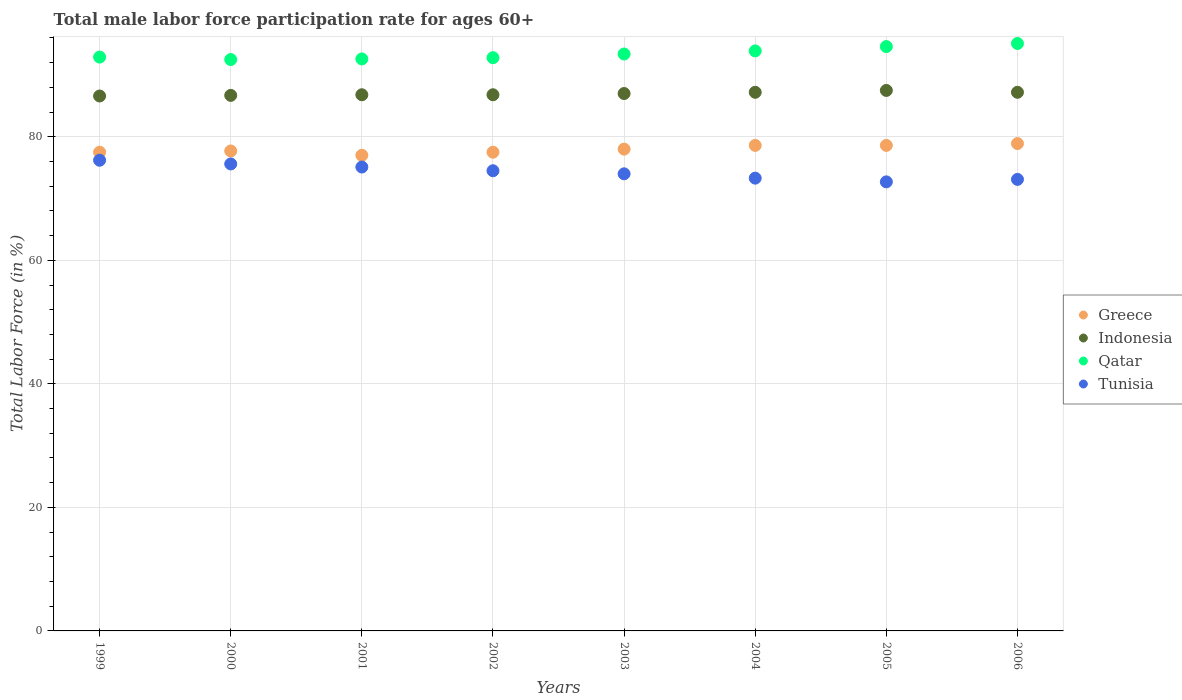How many different coloured dotlines are there?
Provide a short and direct response. 4. Is the number of dotlines equal to the number of legend labels?
Provide a succinct answer. Yes. Across all years, what is the maximum male labor force participation rate in Greece?
Ensure brevity in your answer.  78.9. Across all years, what is the minimum male labor force participation rate in Qatar?
Ensure brevity in your answer.  92.5. What is the total male labor force participation rate in Qatar in the graph?
Make the answer very short. 747.8. What is the difference between the male labor force participation rate in Qatar in 2006 and the male labor force participation rate in Indonesia in 1999?
Keep it short and to the point. 8.5. What is the average male labor force participation rate in Indonesia per year?
Your response must be concise. 86.97. In the year 2001, what is the difference between the male labor force participation rate in Greece and male labor force participation rate in Indonesia?
Offer a very short reply. -9.8. What is the ratio of the male labor force participation rate in Indonesia in 2000 to that in 2006?
Your answer should be very brief. 0.99. Is the difference between the male labor force participation rate in Greece in 2000 and 2005 greater than the difference between the male labor force participation rate in Indonesia in 2000 and 2005?
Your answer should be compact. No. What is the difference between the highest and the second highest male labor force participation rate in Tunisia?
Offer a very short reply. 0.6. What is the difference between the highest and the lowest male labor force participation rate in Indonesia?
Provide a succinct answer. 0.9. In how many years, is the male labor force participation rate in Qatar greater than the average male labor force participation rate in Qatar taken over all years?
Offer a very short reply. 3. Is the sum of the male labor force participation rate in Greece in 2000 and 2002 greater than the maximum male labor force participation rate in Qatar across all years?
Offer a very short reply. Yes. Is it the case that in every year, the sum of the male labor force participation rate in Tunisia and male labor force participation rate in Qatar  is greater than the sum of male labor force participation rate in Indonesia and male labor force participation rate in Greece?
Provide a succinct answer. No. Does the male labor force participation rate in Greece monotonically increase over the years?
Your answer should be very brief. No. Is the male labor force participation rate in Qatar strictly greater than the male labor force participation rate in Greece over the years?
Keep it short and to the point. Yes. How many dotlines are there?
Give a very brief answer. 4. How many years are there in the graph?
Your answer should be compact. 8. What is the difference between two consecutive major ticks on the Y-axis?
Make the answer very short. 20. Does the graph contain any zero values?
Keep it short and to the point. No. Where does the legend appear in the graph?
Offer a terse response. Center right. How are the legend labels stacked?
Keep it short and to the point. Vertical. What is the title of the graph?
Give a very brief answer. Total male labor force participation rate for ages 60+. What is the Total Labor Force (in %) in Greece in 1999?
Your response must be concise. 77.5. What is the Total Labor Force (in %) in Indonesia in 1999?
Your answer should be very brief. 86.6. What is the Total Labor Force (in %) of Qatar in 1999?
Ensure brevity in your answer.  92.9. What is the Total Labor Force (in %) of Tunisia in 1999?
Give a very brief answer. 76.2. What is the Total Labor Force (in %) of Greece in 2000?
Keep it short and to the point. 77.7. What is the Total Labor Force (in %) in Indonesia in 2000?
Make the answer very short. 86.7. What is the Total Labor Force (in %) of Qatar in 2000?
Your answer should be compact. 92.5. What is the Total Labor Force (in %) in Tunisia in 2000?
Ensure brevity in your answer.  75.6. What is the Total Labor Force (in %) of Indonesia in 2001?
Your answer should be compact. 86.8. What is the Total Labor Force (in %) of Qatar in 2001?
Offer a very short reply. 92.6. What is the Total Labor Force (in %) in Tunisia in 2001?
Provide a short and direct response. 75.1. What is the Total Labor Force (in %) of Greece in 2002?
Provide a succinct answer. 77.5. What is the Total Labor Force (in %) in Indonesia in 2002?
Offer a terse response. 86.8. What is the Total Labor Force (in %) in Qatar in 2002?
Provide a short and direct response. 92.8. What is the Total Labor Force (in %) of Tunisia in 2002?
Provide a succinct answer. 74.5. What is the Total Labor Force (in %) of Greece in 2003?
Your answer should be compact. 78. What is the Total Labor Force (in %) in Indonesia in 2003?
Keep it short and to the point. 87. What is the Total Labor Force (in %) in Qatar in 2003?
Offer a terse response. 93.4. What is the Total Labor Force (in %) of Tunisia in 2003?
Your answer should be very brief. 74. What is the Total Labor Force (in %) in Greece in 2004?
Provide a short and direct response. 78.6. What is the Total Labor Force (in %) of Indonesia in 2004?
Ensure brevity in your answer.  87.2. What is the Total Labor Force (in %) of Qatar in 2004?
Provide a short and direct response. 93.9. What is the Total Labor Force (in %) in Tunisia in 2004?
Provide a short and direct response. 73.3. What is the Total Labor Force (in %) of Greece in 2005?
Your response must be concise. 78.6. What is the Total Labor Force (in %) in Indonesia in 2005?
Provide a short and direct response. 87.5. What is the Total Labor Force (in %) in Qatar in 2005?
Your answer should be compact. 94.6. What is the Total Labor Force (in %) of Tunisia in 2005?
Give a very brief answer. 72.7. What is the Total Labor Force (in %) of Greece in 2006?
Give a very brief answer. 78.9. What is the Total Labor Force (in %) in Indonesia in 2006?
Provide a succinct answer. 87.2. What is the Total Labor Force (in %) of Qatar in 2006?
Your answer should be very brief. 95.1. What is the Total Labor Force (in %) of Tunisia in 2006?
Make the answer very short. 73.1. Across all years, what is the maximum Total Labor Force (in %) in Greece?
Offer a terse response. 78.9. Across all years, what is the maximum Total Labor Force (in %) in Indonesia?
Offer a very short reply. 87.5. Across all years, what is the maximum Total Labor Force (in %) of Qatar?
Ensure brevity in your answer.  95.1. Across all years, what is the maximum Total Labor Force (in %) of Tunisia?
Offer a very short reply. 76.2. Across all years, what is the minimum Total Labor Force (in %) of Greece?
Ensure brevity in your answer.  77. Across all years, what is the minimum Total Labor Force (in %) of Indonesia?
Offer a very short reply. 86.6. Across all years, what is the minimum Total Labor Force (in %) of Qatar?
Provide a short and direct response. 92.5. Across all years, what is the minimum Total Labor Force (in %) in Tunisia?
Make the answer very short. 72.7. What is the total Total Labor Force (in %) of Greece in the graph?
Your answer should be very brief. 623.8. What is the total Total Labor Force (in %) of Indonesia in the graph?
Provide a succinct answer. 695.8. What is the total Total Labor Force (in %) of Qatar in the graph?
Make the answer very short. 747.8. What is the total Total Labor Force (in %) of Tunisia in the graph?
Your answer should be very brief. 594.5. What is the difference between the Total Labor Force (in %) in Indonesia in 1999 and that in 2000?
Make the answer very short. -0.1. What is the difference between the Total Labor Force (in %) in Qatar in 1999 and that in 2000?
Offer a terse response. 0.4. What is the difference between the Total Labor Force (in %) of Greece in 1999 and that in 2001?
Your answer should be very brief. 0.5. What is the difference between the Total Labor Force (in %) in Indonesia in 1999 and that in 2001?
Make the answer very short. -0.2. What is the difference between the Total Labor Force (in %) in Tunisia in 1999 and that in 2001?
Offer a very short reply. 1.1. What is the difference between the Total Labor Force (in %) in Indonesia in 1999 and that in 2002?
Your answer should be compact. -0.2. What is the difference between the Total Labor Force (in %) in Tunisia in 1999 and that in 2002?
Your response must be concise. 1.7. What is the difference between the Total Labor Force (in %) of Greece in 1999 and that in 2003?
Make the answer very short. -0.5. What is the difference between the Total Labor Force (in %) of Indonesia in 1999 and that in 2003?
Ensure brevity in your answer.  -0.4. What is the difference between the Total Labor Force (in %) of Qatar in 1999 and that in 2003?
Keep it short and to the point. -0.5. What is the difference between the Total Labor Force (in %) of Indonesia in 1999 and that in 2004?
Offer a very short reply. -0.6. What is the difference between the Total Labor Force (in %) in Qatar in 1999 and that in 2004?
Give a very brief answer. -1. What is the difference between the Total Labor Force (in %) in Tunisia in 1999 and that in 2004?
Your answer should be compact. 2.9. What is the difference between the Total Labor Force (in %) in Indonesia in 1999 and that in 2005?
Your answer should be compact. -0.9. What is the difference between the Total Labor Force (in %) of Tunisia in 1999 and that in 2005?
Offer a terse response. 3.5. What is the difference between the Total Labor Force (in %) in Greece in 1999 and that in 2006?
Your answer should be compact. -1.4. What is the difference between the Total Labor Force (in %) of Indonesia in 1999 and that in 2006?
Offer a very short reply. -0.6. What is the difference between the Total Labor Force (in %) of Qatar in 1999 and that in 2006?
Keep it short and to the point. -2.2. What is the difference between the Total Labor Force (in %) in Indonesia in 2000 and that in 2001?
Your answer should be compact. -0.1. What is the difference between the Total Labor Force (in %) in Qatar in 2000 and that in 2001?
Provide a succinct answer. -0.1. What is the difference between the Total Labor Force (in %) in Tunisia in 2000 and that in 2001?
Offer a terse response. 0.5. What is the difference between the Total Labor Force (in %) of Tunisia in 2000 and that in 2002?
Your answer should be compact. 1.1. What is the difference between the Total Labor Force (in %) in Greece in 2000 and that in 2003?
Offer a very short reply. -0.3. What is the difference between the Total Labor Force (in %) of Indonesia in 2000 and that in 2003?
Provide a short and direct response. -0.3. What is the difference between the Total Labor Force (in %) of Tunisia in 2000 and that in 2003?
Give a very brief answer. 1.6. What is the difference between the Total Labor Force (in %) of Greece in 2000 and that in 2004?
Provide a short and direct response. -0.9. What is the difference between the Total Labor Force (in %) of Tunisia in 2000 and that in 2004?
Provide a short and direct response. 2.3. What is the difference between the Total Labor Force (in %) in Qatar in 2000 and that in 2005?
Give a very brief answer. -2.1. What is the difference between the Total Labor Force (in %) of Tunisia in 2000 and that in 2005?
Make the answer very short. 2.9. What is the difference between the Total Labor Force (in %) of Greece in 2000 and that in 2006?
Keep it short and to the point. -1.2. What is the difference between the Total Labor Force (in %) in Qatar in 2000 and that in 2006?
Ensure brevity in your answer.  -2.6. What is the difference between the Total Labor Force (in %) of Tunisia in 2000 and that in 2006?
Offer a very short reply. 2.5. What is the difference between the Total Labor Force (in %) of Greece in 2001 and that in 2002?
Offer a terse response. -0.5. What is the difference between the Total Labor Force (in %) of Qatar in 2001 and that in 2002?
Make the answer very short. -0.2. What is the difference between the Total Labor Force (in %) of Tunisia in 2001 and that in 2002?
Your response must be concise. 0.6. What is the difference between the Total Labor Force (in %) in Greece in 2001 and that in 2003?
Provide a succinct answer. -1. What is the difference between the Total Labor Force (in %) of Qatar in 2001 and that in 2003?
Offer a very short reply. -0.8. What is the difference between the Total Labor Force (in %) of Greece in 2001 and that in 2004?
Your response must be concise. -1.6. What is the difference between the Total Labor Force (in %) in Indonesia in 2001 and that in 2004?
Make the answer very short. -0.4. What is the difference between the Total Labor Force (in %) of Qatar in 2001 and that in 2004?
Your response must be concise. -1.3. What is the difference between the Total Labor Force (in %) of Tunisia in 2001 and that in 2004?
Your answer should be very brief. 1.8. What is the difference between the Total Labor Force (in %) in Greece in 2001 and that in 2005?
Provide a succinct answer. -1.6. What is the difference between the Total Labor Force (in %) of Tunisia in 2001 and that in 2005?
Offer a very short reply. 2.4. What is the difference between the Total Labor Force (in %) of Greece in 2001 and that in 2006?
Make the answer very short. -1.9. What is the difference between the Total Labor Force (in %) of Qatar in 2001 and that in 2006?
Your response must be concise. -2.5. What is the difference between the Total Labor Force (in %) in Indonesia in 2002 and that in 2003?
Provide a succinct answer. -0.2. What is the difference between the Total Labor Force (in %) in Qatar in 2002 and that in 2003?
Your answer should be very brief. -0.6. What is the difference between the Total Labor Force (in %) in Tunisia in 2002 and that in 2003?
Ensure brevity in your answer.  0.5. What is the difference between the Total Labor Force (in %) in Indonesia in 2002 and that in 2004?
Make the answer very short. -0.4. What is the difference between the Total Labor Force (in %) in Qatar in 2002 and that in 2004?
Provide a succinct answer. -1.1. What is the difference between the Total Labor Force (in %) of Tunisia in 2002 and that in 2004?
Make the answer very short. 1.2. What is the difference between the Total Labor Force (in %) in Qatar in 2002 and that in 2005?
Provide a succinct answer. -1.8. What is the difference between the Total Labor Force (in %) of Indonesia in 2002 and that in 2006?
Provide a succinct answer. -0.4. What is the difference between the Total Labor Force (in %) in Qatar in 2003 and that in 2004?
Make the answer very short. -0.5. What is the difference between the Total Labor Force (in %) in Tunisia in 2003 and that in 2004?
Your answer should be compact. 0.7. What is the difference between the Total Labor Force (in %) in Greece in 2003 and that in 2005?
Give a very brief answer. -0.6. What is the difference between the Total Labor Force (in %) in Indonesia in 2003 and that in 2005?
Offer a very short reply. -0.5. What is the difference between the Total Labor Force (in %) of Tunisia in 2003 and that in 2005?
Provide a succinct answer. 1.3. What is the difference between the Total Labor Force (in %) of Greece in 2004 and that in 2005?
Give a very brief answer. 0. What is the difference between the Total Labor Force (in %) of Indonesia in 2004 and that in 2005?
Offer a very short reply. -0.3. What is the difference between the Total Labor Force (in %) in Tunisia in 2004 and that in 2005?
Keep it short and to the point. 0.6. What is the difference between the Total Labor Force (in %) in Indonesia in 2004 and that in 2006?
Give a very brief answer. 0. What is the difference between the Total Labor Force (in %) in Qatar in 2004 and that in 2006?
Provide a succinct answer. -1.2. What is the difference between the Total Labor Force (in %) in Tunisia in 2004 and that in 2006?
Your answer should be very brief. 0.2. What is the difference between the Total Labor Force (in %) of Greece in 1999 and the Total Labor Force (in %) of Indonesia in 2000?
Ensure brevity in your answer.  -9.2. What is the difference between the Total Labor Force (in %) in Greece in 1999 and the Total Labor Force (in %) in Tunisia in 2000?
Make the answer very short. 1.9. What is the difference between the Total Labor Force (in %) in Indonesia in 1999 and the Total Labor Force (in %) in Qatar in 2000?
Keep it short and to the point. -5.9. What is the difference between the Total Labor Force (in %) in Greece in 1999 and the Total Labor Force (in %) in Qatar in 2001?
Ensure brevity in your answer.  -15.1. What is the difference between the Total Labor Force (in %) in Indonesia in 1999 and the Total Labor Force (in %) in Qatar in 2001?
Offer a terse response. -6. What is the difference between the Total Labor Force (in %) in Indonesia in 1999 and the Total Labor Force (in %) in Tunisia in 2001?
Your answer should be very brief. 11.5. What is the difference between the Total Labor Force (in %) of Greece in 1999 and the Total Labor Force (in %) of Indonesia in 2002?
Make the answer very short. -9.3. What is the difference between the Total Labor Force (in %) of Greece in 1999 and the Total Labor Force (in %) of Qatar in 2002?
Your answer should be very brief. -15.3. What is the difference between the Total Labor Force (in %) in Greece in 1999 and the Total Labor Force (in %) in Tunisia in 2002?
Provide a succinct answer. 3. What is the difference between the Total Labor Force (in %) of Indonesia in 1999 and the Total Labor Force (in %) of Qatar in 2002?
Offer a very short reply. -6.2. What is the difference between the Total Labor Force (in %) of Greece in 1999 and the Total Labor Force (in %) of Qatar in 2003?
Provide a short and direct response. -15.9. What is the difference between the Total Labor Force (in %) of Indonesia in 1999 and the Total Labor Force (in %) of Qatar in 2003?
Your answer should be very brief. -6.8. What is the difference between the Total Labor Force (in %) of Greece in 1999 and the Total Labor Force (in %) of Indonesia in 2004?
Offer a very short reply. -9.7. What is the difference between the Total Labor Force (in %) of Greece in 1999 and the Total Labor Force (in %) of Qatar in 2004?
Your answer should be very brief. -16.4. What is the difference between the Total Labor Force (in %) of Indonesia in 1999 and the Total Labor Force (in %) of Tunisia in 2004?
Provide a succinct answer. 13.3. What is the difference between the Total Labor Force (in %) in Qatar in 1999 and the Total Labor Force (in %) in Tunisia in 2004?
Make the answer very short. 19.6. What is the difference between the Total Labor Force (in %) in Greece in 1999 and the Total Labor Force (in %) in Indonesia in 2005?
Your answer should be very brief. -10. What is the difference between the Total Labor Force (in %) of Greece in 1999 and the Total Labor Force (in %) of Qatar in 2005?
Provide a succinct answer. -17.1. What is the difference between the Total Labor Force (in %) of Greece in 1999 and the Total Labor Force (in %) of Tunisia in 2005?
Offer a terse response. 4.8. What is the difference between the Total Labor Force (in %) in Indonesia in 1999 and the Total Labor Force (in %) in Tunisia in 2005?
Your response must be concise. 13.9. What is the difference between the Total Labor Force (in %) in Qatar in 1999 and the Total Labor Force (in %) in Tunisia in 2005?
Ensure brevity in your answer.  20.2. What is the difference between the Total Labor Force (in %) of Greece in 1999 and the Total Labor Force (in %) of Indonesia in 2006?
Give a very brief answer. -9.7. What is the difference between the Total Labor Force (in %) of Greece in 1999 and the Total Labor Force (in %) of Qatar in 2006?
Keep it short and to the point. -17.6. What is the difference between the Total Labor Force (in %) in Indonesia in 1999 and the Total Labor Force (in %) in Tunisia in 2006?
Ensure brevity in your answer.  13.5. What is the difference between the Total Labor Force (in %) of Qatar in 1999 and the Total Labor Force (in %) of Tunisia in 2006?
Provide a succinct answer. 19.8. What is the difference between the Total Labor Force (in %) in Greece in 2000 and the Total Labor Force (in %) in Qatar in 2001?
Provide a succinct answer. -14.9. What is the difference between the Total Labor Force (in %) in Greece in 2000 and the Total Labor Force (in %) in Tunisia in 2001?
Offer a terse response. 2.6. What is the difference between the Total Labor Force (in %) of Qatar in 2000 and the Total Labor Force (in %) of Tunisia in 2001?
Your response must be concise. 17.4. What is the difference between the Total Labor Force (in %) in Greece in 2000 and the Total Labor Force (in %) in Qatar in 2002?
Ensure brevity in your answer.  -15.1. What is the difference between the Total Labor Force (in %) in Qatar in 2000 and the Total Labor Force (in %) in Tunisia in 2002?
Make the answer very short. 18. What is the difference between the Total Labor Force (in %) in Greece in 2000 and the Total Labor Force (in %) in Indonesia in 2003?
Your answer should be compact. -9.3. What is the difference between the Total Labor Force (in %) in Greece in 2000 and the Total Labor Force (in %) in Qatar in 2003?
Offer a terse response. -15.7. What is the difference between the Total Labor Force (in %) in Greece in 2000 and the Total Labor Force (in %) in Qatar in 2004?
Make the answer very short. -16.2. What is the difference between the Total Labor Force (in %) of Indonesia in 2000 and the Total Labor Force (in %) of Qatar in 2004?
Your answer should be compact. -7.2. What is the difference between the Total Labor Force (in %) in Greece in 2000 and the Total Labor Force (in %) in Indonesia in 2005?
Keep it short and to the point. -9.8. What is the difference between the Total Labor Force (in %) in Greece in 2000 and the Total Labor Force (in %) in Qatar in 2005?
Give a very brief answer. -16.9. What is the difference between the Total Labor Force (in %) of Greece in 2000 and the Total Labor Force (in %) of Tunisia in 2005?
Give a very brief answer. 5. What is the difference between the Total Labor Force (in %) in Indonesia in 2000 and the Total Labor Force (in %) in Tunisia in 2005?
Make the answer very short. 14. What is the difference between the Total Labor Force (in %) of Qatar in 2000 and the Total Labor Force (in %) of Tunisia in 2005?
Give a very brief answer. 19.8. What is the difference between the Total Labor Force (in %) in Greece in 2000 and the Total Labor Force (in %) in Indonesia in 2006?
Provide a succinct answer. -9.5. What is the difference between the Total Labor Force (in %) in Greece in 2000 and the Total Labor Force (in %) in Qatar in 2006?
Provide a short and direct response. -17.4. What is the difference between the Total Labor Force (in %) in Greece in 2000 and the Total Labor Force (in %) in Tunisia in 2006?
Your response must be concise. 4.6. What is the difference between the Total Labor Force (in %) of Indonesia in 2000 and the Total Labor Force (in %) of Tunisia in 2006?
Your response must be concise. 13.6. What is the difference between the Total Labor Force (in %) in Qatar in 2000 and the Total Labor Force (in %) in Tunisia in 2006?
Provide a short and direct response. 19.4. What is the difference between the Total Labor Force (in %) in Greece in 2001 and the Total Labor Force (in %) in Indonesia in 2002?
Give a very brief answer. -9.8. What is the difference between the Total Labor Force (in %) in Greece in 2001 and the Total Labor Force (in %) in Qatar in 2002?
Offer a terse response. -15.8. What is the difference between the Total Labor Force (in %) of Qatar in 2001 and the Total Labor Force (in %) of Tunisia in 2002?
Provide a succinct answer. 18.1. What is the difference between the Total Labor Force (in %) of Greece in 2001 and the Total Labor Force (in %) of Indonesia in 2003?
Offer a terse response. -10. What is the difference between the Total Labor Force (in %) of Greece in 2001 and the Total Labor Force (in %) of Qatar in 2003?
Your response must be concise. -16.4. What is the difference between the Total Labor Force (in %) of Indonesia in 2001 and the Total Labor Force (in %) of Qatar in 2003?
Offer a very short reply. -6.6. What is the difference between the Total Labor Force (in %) in Qatar in 2001 and the Total Labor Force (in %) in Tunisia in 2003?
Offer a terse response. 18.6. What is the difference between the Total Labor Force (in %) in Greece in 2001 and the Total Labor Force (in %) in Qatar in 2004?
Keep it short and to the point. -16.9. What is the difference between the Total Labor Force (in %) in Greece in 2001 and the Total Labor Force (in %) in Tunisia in 2004?
Offer a very short reply. 3.7. What is the difference between the Total Labor Force (in %) of Indonesia in 2001 and the Total Labor Force (in %) of Qatar in 2004?
Ensure brevity in your answer.  -7.1. What is the difference between the Total Labor Force (in %) of Indonesia in 2001 and the Total Labor Force (in %) of Tunisia in 2004?
Provide a short and direct response. 13.5. What is the difference between the Total Labor Force (in %) of Qatar in 2001 and the Total Labor Force (in %) of Tunisia in 2004?
Provide a short and direct response. 19.3. What is the difference between the Total Labor Force (in %) of Greece in 2001 and the Total Labor Force (in %) of Qatar in 2005?
Make the answer very short. -17.6. What is the difference between the Total Labor Force (in %) in Indonesia in 2001 and the Total Labor Force (in %) in Qatar in 2005?
Provide a succinct answer. -7.8. What is the difference between the Total Labor Force (in %) of Indonesia in 2001 and the Total Labor Force (in %) of Tunisia in 2005?
Give a very brief answer. 14.1. What is the difference between the Total Labor Force (in %) in Qatar in 2001 and the Total Labor Force (in %) in Tunisia in 2005?
Your answer should be very brief. 19.9. What is the difference between the Total Labor Force (in %) in Greece in 2001 and the Total Labor Force (in %) in Indonesia in 2006?
Your answer should be very brief. -10.2. What is the difference between the Total Labor Force (in %) of Greece in 2001 and the Total Labor Force (in %) of Qatar in 2006?
Keep it short and to the point. -18.1. What is the difference between the Total Labor Force (in %) of Greece in 2001 and the Total Labor Force (in %) of Tunisia in 2006?
Offer a terse response. 3.9. What is the difference between the Total Labor Force (in %) of Qatar in 2001 and the Total Labor Force (in %) of Tunisia in 2006?
Give a very brief answer. 19.5. What is the difference between the Total Labor Force (in %) in Greece in 2002 and the Total Labor Force (in %) in Qatar in 2003?
Your answer should be compact. -15.9. What is the difference between the Total Labor Force (in %) in Greece in 2002 and the Total Labor Force (in %) in Tunisia in 2003?
Make the answer very short. 3.5. What is the difference between the Total Labor Force (in %) in Indonesia in 2002 and the Total Labor Force (in %) in Qatar in 2003?
Provide a short and direct response. -6.6. What is the difference between the Total Labor Force (in %) of Indonesia in 2002 and the Total Labor Force (in %) of Tunisia in 2003?
Keep it short and to the point. 12.8. What is the difference between the Total Labor Force (in %) of Qatar in 2002 and the Total Labor Force (in %) of Tunisia in 2003?
Provide a succinct answer. 18.8. What is the difference between the Total Labor Force (in %) of Greece in 2002 and the Total Labor Force (in %) of Indonesia in 2004?
Offer a terse response. -9.7. What is the difference between the Total Labor Force (in %) in Greece in 2002 and the Total Labor Force (in %) in Qatar in 2004?
Your answer should be very brief. -16.4. What is the difference between the Total Labor Force (in %) of Greece in 2002 and the Total Labor Force (in %) of Tunisia in 2004?
Your response must be concise. 4.2. What is the difference between the Total Labor Force (in %) of Qatar in 2002 and the Total Labor Force (in %) of Tunisia in 2004?
Offer a very short reply. 19.5. What is the difference between the Total Labor Force (in %) of Greece in 2002 and the Total Labor Force (in %) of Qatar in 2005?
Keep it short and to the point. -17.1. What is the difference between the Total Labor Force (in %) of Indonesia in 2002 and the Total Labor Force (in %) of Tunisia in 2005?
Provide a succinct answer. 14.1. What is the difference between the Total Labor Force (in %) of Qatar in 2002 and the Total Labor Force (in %) of Tunisia in 2005?
Give a very brief answer. 20.1. What is the difference between the Total Labor Force (in %) of Greece in 2002 and the Total Labor Force (in %) of Qatar in 2006?
Make the answer very short. -17.6. What is the difference between the Total Labor Force (in %) in Indonesia in 2002 and the Total Labor Force (in %) in Qatar in 2006?
Keep it short and to the point. -8.3. What is the difference between the Total Labor Force (in %) in Qatar in 2002 and the Total Labor Force (in %) in Tunisia in 2006?
Ensure brevity in your answer.  19.7. What is the difference between the Total Labor Force (in %) of Greece in 2003 and the Total Labor Force (in %) of Indonesia in 2004?
Your answer should be very brief. -9.2. What is the difference between the Total Labor Force (in %) in Greece in 2003 and the Total Labor Force (in %) in Qatar in 2004?
Offer a terse response. -15.9. What is the difference between the Total Labor Force (in %) in Greece in 2003 and the Total Labor Force (in %) in Tunisia in 2004?
Make the answer very short. 4.7. What is the difference between the Total Labor Force (in %) in Indonesia in 2003 and the Total Labor Force (in %) in Tunisia in 2004?
Ensure brevity in your answer.  13.7. What is the difference between the Total Labor Force (in %) in Qatar in 2003 and the Total Labor Force (in %) in Tunisia in 2004?
Your response must be concise. 20.1. What is the difference between the Total Labor Force (in %) of Greece in 2003 and the Total Labor Force (in %) of Qatar in 2005?
Your answer should be compact. -16.6. What is the difference between the Total Labor Force (in %) in Greece in 2003 and the Total Labor Force (in %) in Tunisia in 2005?
Your answer should be compact. 5.3. What is the difference between the Total Labor Force (in %) in Indonesia in 2003 and the Total Labor Force (in %) in Qatar in 2005?
Keep it short and to the point. -7.6. What is the difference between the Total Labor Force (in %) in Qatar in 2003 and the Total Labor Force (in %) in Tunisia in 2005?
Ensure brevity in your answer.  20.7. What is the difference between the Total Labor Force (in %) in Greece in 2003 and the Total Labor Force (in %) in Qatar in 2006?
Keep it short and to the point. -17.1. What is the difference between the Total Labor Force (in %) of Qatar in 2003 and the Total Labor Force (in %) of Tunisia in 2006?
Offer a very short reply. 20.3. What is the difference between the Total Labor Force (in %) in Greece in 2004 and the Total Labor Force (in %) in Qatar in 2005?
Give a very brief answer. -16. What is the difference between the Total Labor Force (in %) in Indonesia in 2004 and the Total Labor Force (in %) in Tunisia in 2005?
Provide a short and direct response. 14.5. What is the difference between the Total Labor Force (in %) of Qatar in 2004 and the Total Labor Force (in %) of Tunisia in 2005?
Offer a terse response. 21.2. What is the difference between the Total Labor Force (in %) of Greece in 2004 and the Total Labor Force (in %) of Qatar in 2006?
Your answer should be compact. -16.5. What is the difference between the Total Labor Force (in %) of Qatar in 2004 and the Total Labor Force (in %) of Tunisia in 2006?
Provide a short and direct response. 20.8. What is the difference between the Total Labor Force (in %) in Greece in 2005 and the Total Labor Force (in %) in Indonesia in 2006?
Your answer should be compact. -8.6. What is the difference between the Total Labor Force (in %) of Greece in 2005 and the Total Labor Force (in %) of Qatar in 2006?
Offer a terse response. -16.5. What is the difference between the Total Labor Force (in %) of Greece in 2005 and the Total Labor Force (in %) of Tunisia in 2006?
Offer a very short reply. 5.5. What is the difference between the Total Labor Force (in %) in Indonesia in 2005 and the Total Labor Force (in %) in Qatar in 2006?
Your answer should be compact. -7.6. What is the difference between the Total Labor Force (in %) in Indonesia in 2005 and the Total Labor Force (in %) in Tunisia in 2006?
Your answer should be compact. 14.4. What is the difference between the Total Labor Force (in %) of Qatar in 2005 and the Total Labor Force (in %) of Tunisia in 2006?
Your answer should be compact. 21.5. What is the average Total Labor Force (in %) in Greece per year?
Make the answer very short. 77.97. What is the average Total Labor Force (in %) of Indonesia per year?
Keep it short and to the point. 86.97. What is the average Total Labor Force (in %) in Qatar per year?
Offer a very short reply. 93.47. What is the average Total Labor Force (in %) of Tunisia per year?
Your answer should be very brief. 74.31. In the year 1999, what is the difference between the Total Labor Force (in %) of Greece and Total Labor Force (in %) of Qatar?
Ensure brevity in your answer.  -15.4. In the year 1999, what is the difference between the Total Labor Force (in %) of Qatar and Total Labor Force (in %) of Tunisia?
Ensure brevity in your answer.  16.7. In the year 2000, what is the difference between the Total Labor Force (in %) of Greece and Total Labor Force (in %) of Indonesia?
Your response must be concise. -9. In the year 2000, what is the difference between the Total Labor Force (in %) of Greece and Total Labor Force (in %) of Qatar?
Your response must be concise. -14.8. In the year 2000, what is the difference between the Total Labor Force (in %) of Greece and Total Labor Force (in %) of Tunisia?
Provide a short and direct response. 2.1. In the year 2000, what is the difference between the Total Labor Force (in %) of Indonesia and Total Labor Force (in %) of Qatar?
Your answer should be very brief. -5.8. In the year 2001, what is the difference between the Total Labor Force (in %) in Greece and Total Labor Force (in %) in Qatar?
Your response must be concise. -15.6. In the year 2001, what is the difference between the Total Labor Force (in %) in Greece and Total Labor Force (in %) in Tunisia?
Ensure brevity in your answer.  1.9. In the year 2001, what is the difference between the Total Labor Force (in %) in Qatar and Total Labor Force (in %) in Tunisia?
Offer a terse response. 17.5. In the year 2002, what is the difference between the Total Labor Force (in %) in Greece and Total Labor Force (in %) in Indonesia?
Offer a terse response. -9.3. In the year 2002, what is the difference between the Total Labor Force (in %) in Greece and Total Labor Force (in %) in Qatar?
Provide a succinct answer. -15.3. In the year 2002, what is the difference between the Total Labor Force (in %) of Greece and Total Labor Force (in %) of Tunisia?
Keep it short and to the point. 3. In the year 2002, what is the difference between the Total Labor Force (in %) of Indonesia and Total Labor Force (in %) of Qatar?
Your response must be concise. -6. In the year 2002, what is the difference between the Total Labor Force (in %) of Indonesia and Total Labor Force (in %) of Tunisia?
Make the answer very short. 12.3. In the year 2003, what is the difference between the Total Labor Force (in %) in Greece and Total Labor Force (in %) in Indonesia?
Make the answer very short. -9. In the year 2003, what is the difference between the Total Labor Force (in %) in Greece and Total Labor Force (in %) in Qatar?
Offer a very short reply. -15.4. In the year 2003, what is the difference between the Total Labor Force (in %) in Indonesia and Total Labor Force (in %) in Qatar?
Your answer should be compact. -6.4. In the year 2003, what is the difference between the Total Labor Force (in %) in Qatar and Total Labor Force (in %) in Tunisia?
Provide a short and direct response. 19.4. In the year 2004, what is the difference between the Total Labor Force (in %) of Greece and Total Labor Force (in %) of Qatar?
Your answer should be compact. -15.3. In the year 2004, what is the difference between the Total Labor Force (in %) in Greece and Total Labor Force (in %) in Tunisia?
Make the answer very short. 5.3. In the year 2004, what is the difference between the Total Labor Force (in %) in Indonesia and Total Labor Force (in %) in Tunisia?
Offer a terse response. 13.9. In the year 2004, what is the difference between the Total Labor Force (in %) in Qatar and Total Labor Force (in %) in Tunisia?
Provide a succinct answer. 20.6. In the year 2005, what is the difference between the Total Labor Force (in %) in Indonesia and Total Labor Force (in %) in Qatar?
Give a very brief answer. -7.1. In the year 2005, what is the difference between the Total Labor Force (in %) of Qatar and Total Labor Force (in %) of Tunisia?
Keep it short and to the point. 21.9. In the year 2006, what is the difference between the Total Labor Force (in %) of Greece and Total Labor Force (in %) of Qatar?
Offer a terse response. -16.2. In the year 2006, what is the difference between the Total Labor Force (in %) in Greece and Total Labor Force (in %) in Tunisia?
Provide a short and direct response. 5.8. In the year 2006, what is the difference between the Total Labor Force (in %) of Indonesia and Total Labor Force (in %) of Tunisia?
Give a very brief answer. 14.1. In the year 2006, what is the difference between the Total Labor Force (in %) of Qatar and Total Labor Force (in %) of Tunisia?
Your answer should be very brief. 22. What is the ratio of the Total Labor Force (in %) in Greece in 1999 to that in 2000?
Your response must be concise. 1. What is the ratio of the Total Labor Force (in %) in Qatar in 1999 to that in 2000?
Make the answer very short. 1. What is the ratio of the Total Labor Force (in %) in Tunisia in 1999 to that in 2000?
Ensure brevity in your answer.  1.01. What is the ratio of the Total Labor Force (in %) of Greece in 1999 to that in 2001?
Offer a terse response. 1.01. What is the ratio of the Total Labor Force (in %) of Tunisia in 1999 to that in 2001?
Offer a very short reply. 1.01. What is the ratio of the Total Labor Force (in %) of Indonesia in 1999 to that in 2002?
Provide a succinct answer. 1. What is the ratio of the Total Labor Force (in %) in Tunisia in 1999 to that in 2002?
Your answer should be compact. 1.02. What is the ratio of the Total Labor Force (in %) of Indonesia in 1999 to that in 2003?
Make the answer very short. 1. What is the ratio of the Total Labor Force (in %) in Qatar in 1999 to that in 2003?
Provide a succinct answer. 0.99. What is the ratio of the Total Labor Force (in %) of Tunisia in 1999 to that in 2003?
Give a very brief answer. 1.03. What is the ratio of the Total Labor Force (in %) in Qatar in 1999 to that in 2004?
Offer a terse response. 0.99. What is the ratio of the Total Labor Force (in %) in Tunisia in 1999 to that in 2004?
Provide a short and direct response. 1.04. What is the ratio of the Total Labor Force (in %) of Greece in 1999 to that in 2005?
Provide a short and direct response. 0.99. What is the ratio of the Total Labor Force (in %) of Indonesia in 1999 to that in 2005?
Offer a very short reply. 0.99. What is the ratio of the Total Labor Force (in %) of Tunisia in 1999 to that in 2005?
Offer a very short reply. 1.05. What is the ratio of the Total Labor Force (in %) in Greece in 1999 to that in 2006?
Ensure brevity in your answer.  0.98. What is the ratio of the Total Labor Force (in %) in Indonesia in 1999 to that in 2006?
Offer a very short reply. 0.99. What is the ratio of the Total Labor Force (in %) of Qatar in 1999 to that in 2006?
Offer a terse response. 0.98. What is the ratio of the Total Labor Force (in %) in Tunisia in 1999 to that in 2006?
Keep it short and to the point. 1.04. What is the ratio of the Total Labor Force (in %) in Greece in 2000 to that in 2001?
Your answer should be very brief. 1.01. What is the ratio of the Total Labor Force (in %) in Indonesia in 2000 to that in 2001?
Ensure brevity in your answer.  1. What is the ratio of the Total Labor Force (in %) of Tunisia in 2000 to that in 2001?
Your answer should be compact. 1.01. What is the ratio of the Total Labor Force (in %) of Greece in 2000 to that in 2002?
Your response must be concise. 1. What is the ratio of the Total Labor Force (in %) in Tunisia in 2000 to that in 2002?
Provide a succinct answer. 1.01. What is the ratio of the Total Labor Force (in %) in Greece in 2000 to that in 2003?
Offer a very short reply. 1. What is the ratio of the Total Labor Force (in %) of Indonesia in 2000 to that in 2003?
Your response must be concise. 1. What is the ratio of the Total Labor Force (in %) of Qatar in 2000 to that in 2003?
Offer a very short reply. 0.99. What is the ratio of the Total Labor Force (in %) of Tunisia in 2000 to that in 2003?
Make the answer very short. 1.02. What is the ratio of the Total Labor Force (in %) of Greece in 2000 to that in 2004?
Offer a very short reply. 0.99. What is the ratio of the Total Labor Force (in %) in Indonesia in 2000 to that in 2004?
Your response must be concise. 0.99. What is the ratio of the Total Labor Force (in %) in Qatar in 2000 to that in 2004?
Offer a terse response. 0.99. What is the ratio of the Total Labor Force (in %) in Tunisia in 2000 to that in 2004?
Your response must be concise. 1.03. What is the ratio of the Total Labor Force (in %) of Indonesia in 2000 to that in 2005?
Make the answer very short. 0.99. What is the ratio of the Total Labor Force (in %) of Qatar in 2000 to that in 2005?
Ensure brevity in your answer.  0.98. What is the ratio of the Total Labor Force (in %) in Tunisia in 2000 to that in 2005?
Give a very brief answer. 1.04. What is the ratio of the Total Labor Force (in %) of Qatar in 2000 to that in 2006?
Make the answer very short. 0.97. What is the ratio of the Total Labor Force (in %) of Tunisia in 2000 to that in 2006?
Offer a terse response. 1.03. What is the ratio of the Total Labor Force (in %) of Indonesia in 2001 to that in 2002?
Your answer should be very brief. 1. What is the ratio of the Total Labor Force (in %) in Qatar in 2001 to that in 2002?
Provide a short and direct response. 1. What is the ratio of the Total Labor Force (in %) of Tunisia in 2001 to that in 2002?
Keep it short and to the point. 1.01. What is the ratio of the Total Labor Force (in %) in Greece in 2001 to that in 2003?
Your answer should be compact. 0.99. What is the ratio of the Total Labor Force (in %) in Tunisia in 2001 to that in 2003?
Your answer should be very brief. 1.01. What is the ratio of the Total Labor Force (in %) in Greece in 2001 to that in 2004?
Your response must be concise. 0.98. What is the ratio of the Total Labor Force (in %) of Indonesia in 2001 to that in 2004?
Provide a succinct answer. 1. What is the ratio of the Total Labor Force (in %) of Qatar in 2001 to that in 2004?
Make the answer very short. 0.99. What is the ratio of the Total Labor Force (in %) of Tunisia in 2001 to that in 2004?
Keep it short and to the point. 1.02. What is the ratio of the Total Labor Force (in %) of Greece in 2001 to that in 2005?
Your response must be concise. 0.98. What is the ratio of the Total Labor Force (in %) in Indonesia in 2001 to that in 2005?
Your answer should be compact. 0.99. What is the ratio of the Total Labor Force (in %) of Qatar in 2001 to that in 2005?
Provide a short and direct response. 0.98. What is the ratio of the Total Labor Force (in %) of Tunisia in 2001 to that in 2005?
Keep it short and to the point. 1.03. What is the ratio of the Total Labor Force (in %) of Greece in 2001 to that in 2006?
Ensure brevity in your answer.  0.98. What is the ratio of the Total Labor Force (in %) of Indonesia in 2001 to that in 2006?
Give a very brief answer. 1. What is the ratio of the Total Labor Force (in %) in Qatar in 2001 to that in 2006?
Offer a terse response. 0.97. What is the ratio of the Total Labor Force (in %) of Tunisia in 2001 to that in 2006?
Provide a short and direct response. 1.03. What is the ratio of the Total Labor Force (in %) in Greece in 2002 to that in 2003?
Keep it short and to the point. 0.99. What is the ratio of the Total Labor Force (in %) in Indonesia in 2002 to that in 2003?
Your answer should be compact. 1. What is the ratio of the Total Labor Force (in %) of Tunisia in 2002 to that in 2003?
Provide a short and direct response. 1.01. What is the ratio of the Total Labor Force (in %) of Greece in 2002 to that in 2004?
Give a very brief answer. 0.99. What is the ratio of the Total Labor Force (in %) of Indonesia in 2002 to that in 2004?
Provide a succinct answer. 1. What is the ratio of the Total Labor Force (in %) in Qatar in 2002 to that in 2004?
Provide a succinct answer. 0.99. What is the ratio of the Total Labor Force (in %) of Tunisia in 2002 to that in 2004?
Ensure brevity in your answer.  1.02. What is the ratio of the Total Labor Force (in %) of Greece in 2002 to that in 2005?
Ensure brevity in your answer.  0.99. What is the ratio of the Total Labor Force (in %) of Tunisia in 2002 to that in 2005?
Provide a short and direct response. 1.02. What is the ratio of the Total Labor Force (in %) in Greece in 2002 to that in 2006?
Your response must be concise. 0.98. What is the ratio of the Total Labor Force (in %) in Qatar in 2002 to that in 2006?
Provide a succinct answer. 0.98. What is the ratio of the Total Labor Force (in %) of Tunisia in 2002 to that in 2006?
Your answer should be compact. 1.02. What is the ratio of the Total Labor Force (in %) of Indonesia in 2003 to that in 2004?
Offer a terse response. 1. What is the ratio of the Total Labor Force (in %) of Tunisia in 2003 to that in 2004?
Keep it short and to the point. 1.01. What is the ratio of the Total Labor Force (in %) in Greece in 2003 to that in 2005?
Offer a very short reply. 0.99. What is the ratio of the Total Labor Force (in %) of Qatar in 2003 to that in 2005?
Your answer should be very brief. 0.99. What is the ratio of the Total Labor Force (in %) of Tunisia in 2003 to that in 2005?
Your response must be concise. 1.02. What is the ratio of the Total Labor Force (in %) in Indonesia in 2003 to that in 2006?
Your response must be concise. 1. What is the ratio of the Total Labor Force (in %) in Qatar in 2003 to that in 2006?
Ensure brevity in your answer.  0.98. What is the ratio of the Total Labor Force (in %) of Tunisia in 2003 to that in 2006?
Your answer should be compact. 1.01. What is the ratio of the Total Labor Force (in %) of Qatar in 2004 to that in 2005?
Provide a succinct answer. 0.99. What is the ratio of the Total Labor Force (in %) of Tunisia in 2004 to that in 2005?
Provide a succinct answer. 1.01. What is the ratio of the Total Labor Force (in %) in Greece in 2004 to that in 2006?
Provide a short and direct response. 1. What is the ratio of the Total Labor Force (in %) in Qatar in 2004 to that in 2006?
Provide a succinct answer. 0.99. What is the ratio of the Total Labor Force (in %) of Tunisia in 2004 to that in 2006?
Keep it short and to the point. 1. What is the ratio of the Total Labor Force (in %) of Indonesia in 2005 to that in 2006?
Give a very brief answer. 1. What is the difference between the highest and the second highest Total Labor Force (in %) of Indonesia?
Offer a very short reply. 0.3. What is the difference between the highest and the second highest Total Labor Force (in %) in Qatar?
Make the answer very short. 0.5. What is the difference between the highest and the second highest Total Labor Force (in %) in Tunisia?
Your answer should be very brief. 0.6. What is the difference between the highest and the lowest Total Labor Force (in %) in Greece?
Provide a short and direct response. 1.9. 